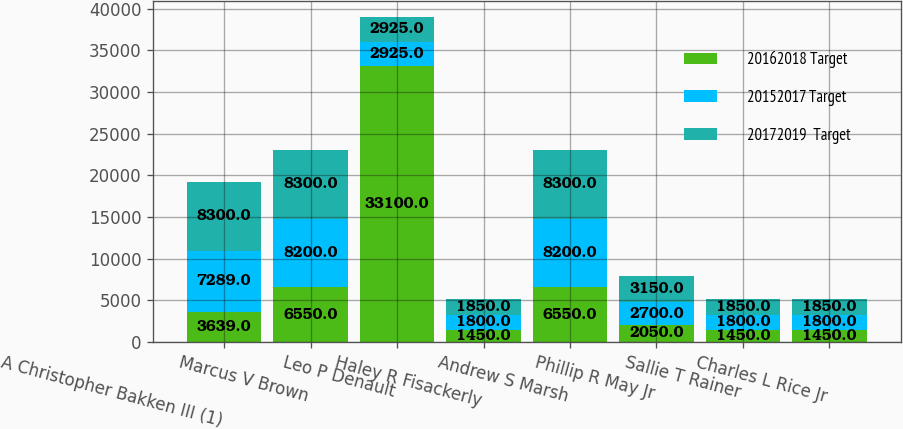<chart> <loc_0><loc_0><loc_500><loc_500><stacked_bar_chart><ecel><fcel>A Christopher Bakken III (1)<fcel>Marcus V Brown<fcel>Leo P Denault<fcel>Haley R Fisackerly<fcel>Andrew S Marsh<fcel>Phillip R May Jr<fcel>Sallie T Rainer<fcel>Charles L Rice Jr<nl><fcel>20162018 Target<fcel>3639<fcel>6550<fcel>33100<fcel>1450<fcel>6550<fcel>2050<fcel>1450<fcel>1450<nl><fcel>20152017 Target<fcel>7289<fcel>8200<fcel>2925<fcel>1800<fcel>8200<fcel>2700<fcel>1800<fcel>1800<nl><fcel>20172019  Target<fcel>8300<fcel>8300<fcel>2925<fcel>1850<fcel>8300<fcel>3150<fcel>1850<fcel>1850<nl></chart> 